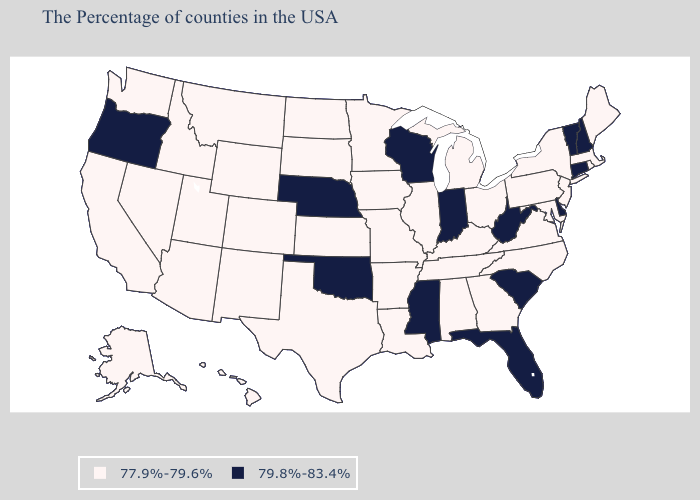Name the states that have a value in the range 77.9%-79.6%?
Keep it brief. Maine, Massachusetts, Rhode Island, New York, New Jersey, Maryland, Pennsylvania, Virginia, North Carolina, Ohio, Georgia, Michigan, Kentucky, Alabama, Tennessee, Illinois, Louisiana, Missouri, Arkansas, Minnesota, Iowa, Kansas, Texas, South Dakota, North Dakota, Wyoming, Colorado, New Mexico, Utah, Montana, Arizona, Idaho, Nevada, California, Washington, Alaska, Hawaii. What is the highest value in the South ?
Give a very brief answer. 79.8%-83.4%. What is the highest value in the West ?
Give a very brief answer. 79.8%-83.4%. Name the states that have a value in the range 77.9%-79.6%?
Keep it brief. Maine, Massachusetts, Rhode Island, New York, New Jersey, Maryland, Pennsylvania, Virginia, North Carolina, Ohio, Georgia, Michigan, Kentucky, Alabama, Tennessee, Illinois, Louisiana, Missouri, Arkansas, Minnesota, Iowa, Kansas, Texas, South Dakota, North Dakota, Wyoming, Colorado, New Mexico, Utah, Montana, Arizona, Idaho, Nevada, California, Washington, Alaska, Hawaii. What is the lowest value in the USA?
Give a very brief answer. 77.9%-79.6%. Does Nebraska have the highest value in the MidWest?
Short answer required. Yes. Among the states that border New Mexico , does Oklahoma have the lowest value?
Quick response, please. No. What is the value of Montana?
Keep it brief. 77.9%-79.6%. Does Texas have the highest value in the South?
Short answer required. No. What is the value of Maine?
Answer briefly. 77.9%-79.6%. What is the value of Virginia?
Keep it brief. 77.9%-79.6%. Is the legend a continuous bar?
Be succinct. No. Does the map have missing data?
Answer briefly. No. Does Oklahoma have the highest value in the USA?
Answer briefly. Yes. 